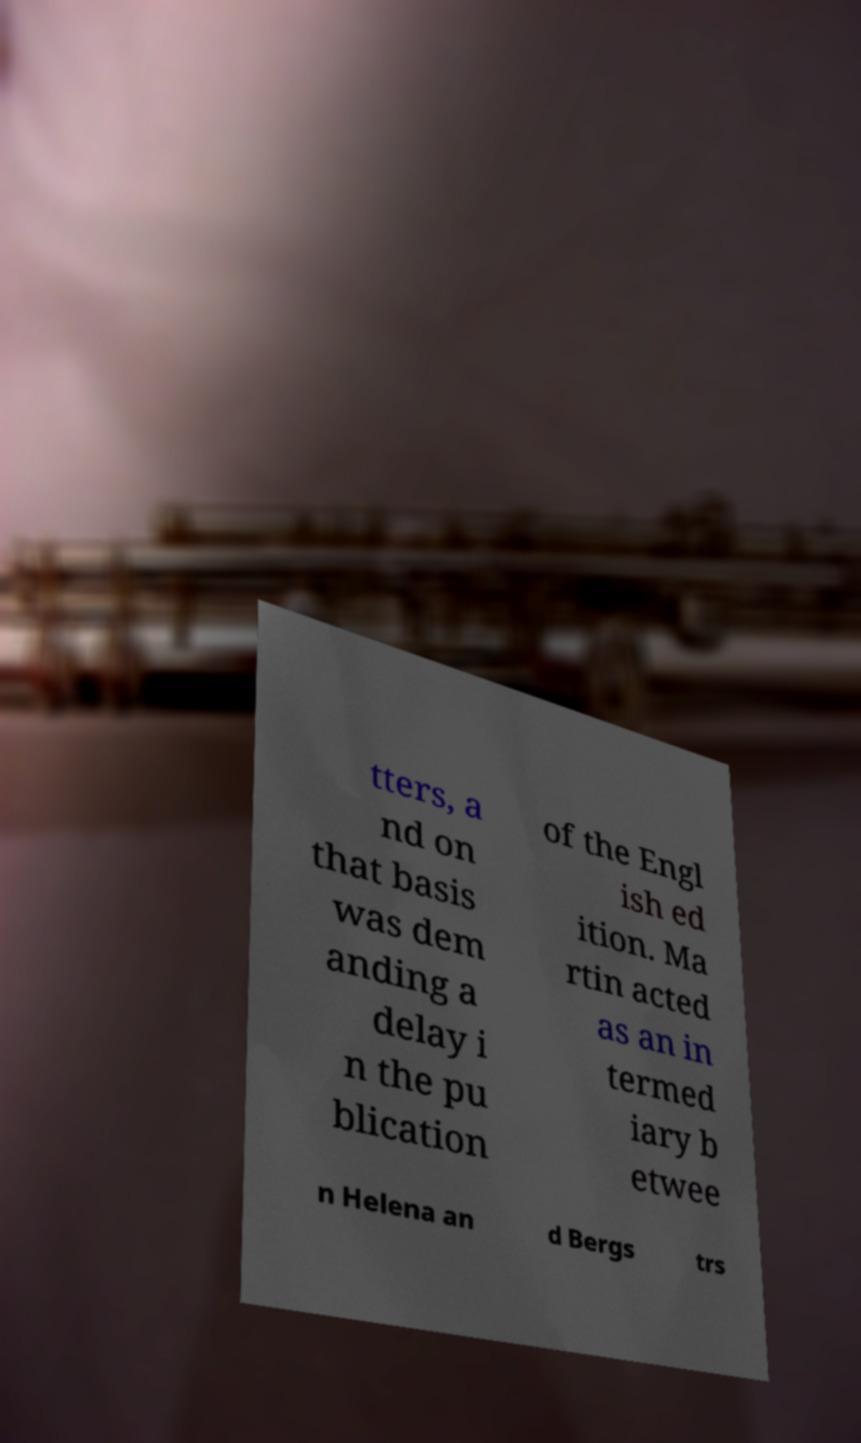Could you extract and type out the text from this image? tters, a nd on that basis was dem anding a delay i n the pu blication of the Engl ish ed ition. Ma rtin acted as an in termed iary b etwee n Helena an d Bergs trs 